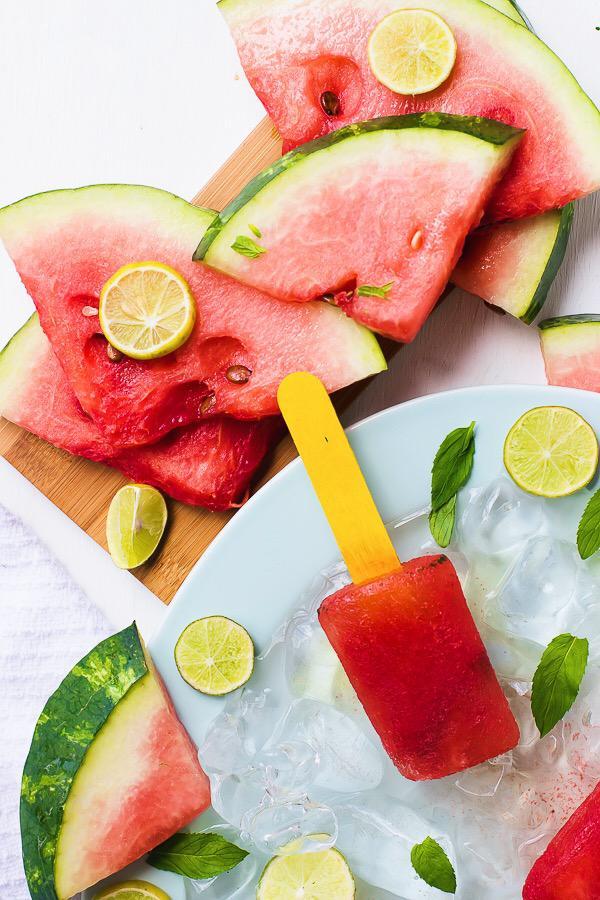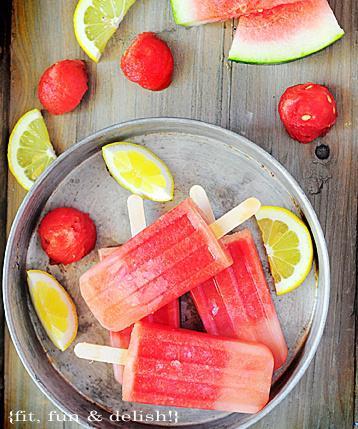The first image is the image on the left, the second image is the image on the right. Examine the images to the left and right. Is the description "Each of the images features fresh watermelon slices along with popsicles." accurate? Answer yes or no. Yes. The first image is the image on the left, the second image is the image on the right. Examine the images to the left and right. Is the description "An image shows a whole lemon along with watermelon imagery." accurate? Answer yes or no. No. 